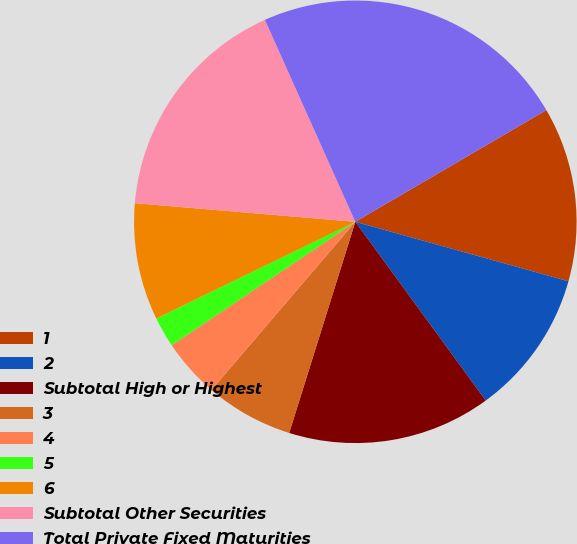Convert chart. <chart><loc_0><loc_0><loc_500><loc_500><pie_chart><fcel>1<fcel>2<fcel>Subtotal High or Highest<fcel>3<fcel>4<fcel>5<fcel>6<fcel>Subtotal Other Securities<fcel>Total Private Fixed Maturities<nl><fcel>12.75%<fcel>10.64%<fcel>14.86%<fcel>6.43%<fcel>4.32%<fcel>2.22%<fcel>8.54%<fcel>16.96%<fcel>23.28%<nl></chart> 